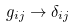<formula> <loc_0><loc_0><loc_500><loc_500>g _ { i j } \to \delta _ { i j }</formula> 